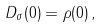<formula> <loc_0><loc_0><loc_500><loc_500>D _ { \sigma } ( 0 ) = \rho ( 0 ) \, ,</formula> 